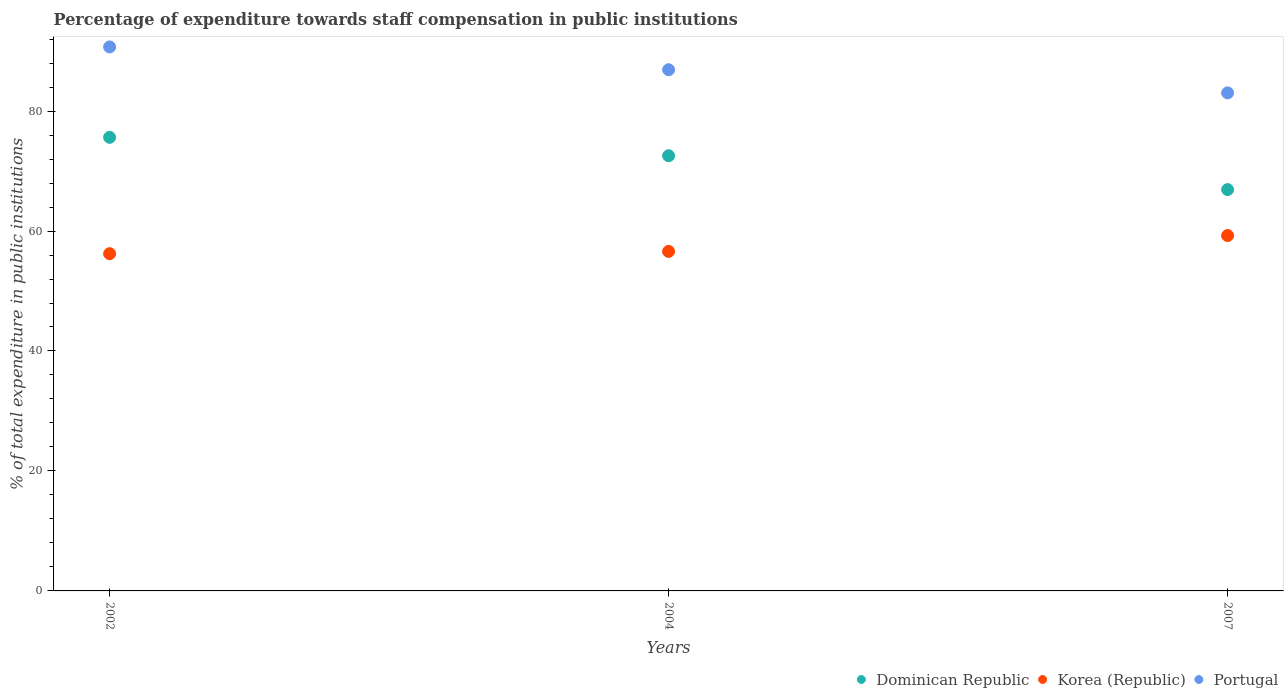How many different coloured dotlines are there?
Give a very brief answer. 3. Is the number of dotlines equal to the number of legend labels?
Offer a very short reply. Yes. What is the percentage of expenditure towards staff compensation in Dominican Republic in 2007?
Keep it short and to the point. 66.91. Across all years, what is the maximum percentage of expenditure towards staff compensation in Portugal?
Keep it short and to the point. 90.69. Across all years, what is the minimum percentage of expenditure towards staff compensation in Portugal?
Offer a very short reply. 83.03. In which year was the percentage of expenditure towards staff compensation in Portugal maximum?
Your response must be concise. 2002. In which year was the percentage of expenditure towards staff compensation in Portugal minimum?
Your answer should be very brief. 2007. What is the total percentage of expenditure towards staff compensation in Dominican Republic in the graph?
Ensure brevity in your answer.  215.08. What is the difference between the percentage of expenditure towards staff compensation in Korea (Republic) in 2004 and that in 2007?
Give a very brief answer. -2.64. What is the difference between the percentage of expenditure towards staff compensation in Korea (Republic) in 2002 and the percentage of expenditure towards staff compensation in Portugal in 2007?
Make the answer very short. -26.81. What is the average percentage of expenditure towards staff compensation in Dominican Republic per year?
Keep it short and to the point. 71.69. In the year 2002, what is the difference between the percentage of expenditure towards staff compensation in Portugal and percentage of expenditure towards staff compensation in Dominican Republic?
Keep it short and to the point. 15.07. What is the ratio of the percentage of expenditure towards staff compensation in Korea (Republic) in 2004 to that in 2007?
Provide a short and direct response. 0.96. Is the difference between the percentage of expenditure towards staff compensation in Portugal in 2004 and 2007 greater than the difference between the percentage of expenditure towards staff compensation in Dominican Republic in 2004 and 2007?
Ensure brevity in your answer.  No. What is the difference between the highest and the second highest percentage of expenditure towards staff compensation in Dominican Republic?
Keep it short and to the point. 3.06. What is the difference between the highest and the lowest percentage of expenditure towards staff compensation in Portugal?
Provide a short and direct response. 7.66. Is the sum of the percentage of expenditure towards staff compensation in Dominican Republic in 2002 and 2004 greater than the maximum percentage of expenditure towards staff compensation in Korea (Republic) across all years?
Offer a terse response. Yes. Does the percentage of expenditure towards staff compensation in Dominican Republic monotonically increase over the years?
Offer a very short reply. No. Is the percentage of expenditure towards staff compensation in Korea (Republic) strictly greater than the percentage of expenditure towards staff compensation in Dominican Republic over the years?
Your response must be concise. No. Is the percentage of expenditure towards staff compensation in Dominican Republic strictly less than the percentage of expenditure towards staff compensation in Portugal over the years?
Give a very brief answer. Yes. How many dotlines are there?
Provide a succinct answer. 3. What is the difference between two consecutive major ticks on the Y-axis?
Provide a succinct answer. 20. Does the graph contain any zero values?
Your answer should be compact. No. Where does the legend appear in the graph?
Your answer should be very brief. Bottom right. What is the title of the graph?
Provide a short and direct response. Percentage of expenditure towards staff compensation in public institutions. What is the label or title of the Y-axis?
Ensure brevity in your answer.  % of total expenditure in public institutions. What is the % of total expenditure in public institutions in Dominican Republic in 2002?
Keep it short and to the point. 75.62. What is the % of total expenditure in public institutions in Korea (Republic) in 2002?
Offer a very short reply. 56.22. What is the % of total expenditure in public institutions in Portugal in 2002?
Keep it short and to the point. 90.69. What is the % of total expenditure in public institutions of Dominican Republic in 2004?
Your answer should be compact. 72.55. What is the % of total expenditure in public institutions of Korea (Republic) in 2004?
Give a very brief answer. 56.6. What is the % of total expenditure in public institutions in Portugal in 2004?
Offer a terse response. 86.89. What is the % of total expenditure in public institutions in Dominican Republic in 2007?
Ensure brevity in your answer.  66.91. What is the % of total expenditure in public institutions of Korea (Republic) in 2007?
Offer a very short reply. 59.25. What is the % of total expenditure in public institutions in Portugal in 2007?
Offer a terse response. 83.03. Across all years, what is the maximum % of total expenditure in public institutions of Dominican Republic?
Ensure brevity in your answer.  75.62. Across all years, what is the maximum % of total expenditure in public institutions of Korea (Republic)?
Offer a very short reply. 59.25. Across all years, what is the maximum % of total expenditure in public institutions in Portugal?
Offer a very short reply. 90.69. Across all years, what is the minimum % of total expenditure in public institutions in Dominican Republic?
Provide a succinct answer. 66.91. Across all years, what is the minimum % of total expenditure in public institutions in Korea (Republic)?
Your response must be concise. 56.22. Across all years, what is the minimum % of total expenditure in public institutions in Portugal?
Provide a succinct answer. 83.03. What is the total % of total expenditure in public institutions in Dominican Republic in the graph?
Keep it short and to the point. 215.08. What is the total % of total expenditure in public institutions of Korea (Republic) in the graph?
Your answer should be compact. 172.07. What is the total % of total expenditure in public institutions of Portugal in the graph?
Your answer should be very brief. 260.61. What is the difference between the % of total expenditure in public institutions of Dominican Republic in 2002 and that in 2004?
Keep it short and to the point. 3.06. What is the difference between the % of total expenditure in public institutions in Korea (Republic) in 2002 and that in 2004?
Offer a terse response. -0.38. What is the difference between the % of total expenditure in public institutions in Portugal in 2002 and that in 2004?
Ensure brevity in your answer.  3.81. What is the difference between the % of total expenditure in public institutions of Dominican Republic in 2002 and that in 2007?
Your answer should be very brief. 8.71. What is the difference between the % of total expenditure in public institutions of Korea (Republic) in 2002 and that in 2007?
Keep it short and to the point. -3.03. What is the difference between the % of total expenditure in public institutions of Portugal in 2002 and that in 2007?
Provide a short and direct response. 7.66. What is the difference between the % of total expenditure in public institutions in Dominican Republic in 2004 and that in 2007?
Offer a very short reply. 5.65. What is the difference between the % of total expenditure in public institutions of Korea (Republic) in 2004 and that in 2007?
Your response must be concise. -2.64. What is the difference between the % of total expenditure in public institutions of Portugal in 2004 and that in 2007?
Provide a short and direct response. 3.86. What is the difference between the % of total expenditure in public institutions in Dominican Republic in 2002 and the % of total expenditure in public institutions in Korea (Republic) in 2004?
Provide a short and direct response. 19.02. What is the difference between the % of total expenditure in public institutions of Dominican Republic in 2002 and the % of total expenditure in public institutions of Portugal in 2004?
Make the answer very short. -11.27. What is the difference between the % of total expenditure in public institutions in Korea (Republic) in 2002 and the % of total expenditure in public institutions in Portugal in 2004?
Offer a very short reply. -30.67. What is the difference between the % of total expenditure in public institutions in Dominican Republic in 2002 and the % of total expenditure in public institutions in Korea (Republic) in 2007?
Offer a terse response. 16.37. What is the difference between the % of total expenditure in public institutions of Dominican Republic in 2002 and the % of total expenditure in public institutions of Portugal in 2007?
Keep it short and to the point. -7.41. What is the difference between the % of total expenditure in public institutions in Korea (Republic) in 2002 and the % of total expenditure in public institutions in Portugal in 2007?
Make the answer very short. -26.81. What is the difference between the % of total expenditure in public institutions in Dominican Republic in 2004 and the % of total expenditure in public institutions in Korea (Republic) in 2007?
Your response must be concise. 13.31. What is the difference between the % of total expenditure in public institutions in Dominican Republic in 2004 and the % of total expenditure in public institutions in Portugal in 2007?
Ensure brevity in your answer.  -10.48. What is the difference between the % of total expenditure in public institutions of Korea (Republic) in 2004 and the % of total expenditure in public institutions of Portugal in 2007?
Make the answer very short. -26.43. What is the average % of total expenditure in public institutions of Dominican Republic per year?
Your answer should be compact. 71.69. What is the average % of total expenditure in public institutions in Korea (Republic) per year?
Keep it short and to the point. 57.36. What is the average % of total expenditure in public institutions of Portugal per year?
Offer a terse response. 86.87. In the year 2002, what is the difference between the % of total expenditure in public institutions in Dominican Republic and % of total expenditure in public institutions in Korea (Republic)?
Your answer should be very brief. 19.4. In the year 2002, what is the difference between the % of total expenditure in public institutions in Dominican Republic and % of total expenditure in public institutions in Portugal?
Give a very brief answer. -15.07. In the year 2002, what is the difference between the % of total expenditure in public institutions of Korea (Republic) and % of total expenditure in public institutions of Portugal?
Keep it short and to the point. -34.47. In the year 2004, what is the difference between the % of total expenditure in public institutions of Dominican Republic and % of total expenditure in public institutions of Korea (Republic)?
Your answer should be compact. 15.95. In the year 2004, what is the difference between the % of total expenditure in public institutions of Dominican Republic and % of total expenditure in public institutions of Portugal?
Ensure brevity in your answer.  -14.33. In the year 2004, what is the difference between the % of total expenditure in public institutions of Korea (Republic) and % of total expenditure in public institutions of Portugal?
Your response must be concise. -30.29. In the year 2007, what is the difference between the % of total expenditure in public institutions of Dominican Republic and % of total expenditure in public institutions of Korea (Republic)?
Your response must be concise. 7.66. In the year 2007, what is the difference between the % of total expenditure in public institutions in Dominican Republic and % of total expenditure in public institutions in Portugal?
Provide a succinct answer. -16.12. In the year 2007, what is the difference between the % of total expenditure in public institutions of Korea (Republic) and % of total expenditure in public institutions of Portugal?
Ensure brevity in your answer.  -23.78. What is the ratio of the % of total expenditure in public institutions of Dominican Republic in 2002 to that in 2004?
Offer a terse response. 1.04. What is the ratio of the % of total expenditure in public institutions of Portugal in 2002 to that in 2004?
Your answer should be very brief. 1.04. What is the ratio of the % of total expenditure in public institutions in Dominican Republic in 2002 to that in 2007?
Provide a succinct answer. 1.13. What is the ratio of the % of total expenditure in public institutions of Korea (Republic) in 2002 to that in 2007?
Your response must be concise. 0.95. What is the ratio of the % of total expenditure in public institutions of Portugal in 2002 to that in 2007?
Ensure brevity in your answer.  1.09. What is the ratio of the % of total expenditure in public institutions in Dominican Republic in 2004 to that in 2007?
Keep it short and to the point. 1.08. What is the ratio of the % of total expenditure in public institutions of Korea (Republic) in 2004 to that in 2007?
Your answer should be very brief. 0.96. What is the ratio of the % of total expenditure in public institutions of Portugal in 2004 to that in 2007?
Your answer should be compact. 1.05. What is the difference between the highest and the second highest % of total expenditure in public institutions of Dominican Republic?
Ensure brevity in your answer.  3.06. What is the difference between the highest and the second highest % of total expenditure in public institutions in Korea (Republic)?
Provide a succinct answer. 2.64. What is the difference between the highest and the second highest % of total expenditure in public institutions of Portugal?
Your answer should be compact. 3.81. What is the difference between the highest and the lowest % of total expenditure in public institutions in Dominican Republic?
Provide a succinct answer. 8.71. What is the difference between the highest and the lowest % of total expenditure in public institutions of Korea (Republic)?
Offer a terse response. 3.03. What is the difference between the highest and the lowest % of total expenditure in public institutions of Portugal?
Keep it short and to the point. 7.66. 